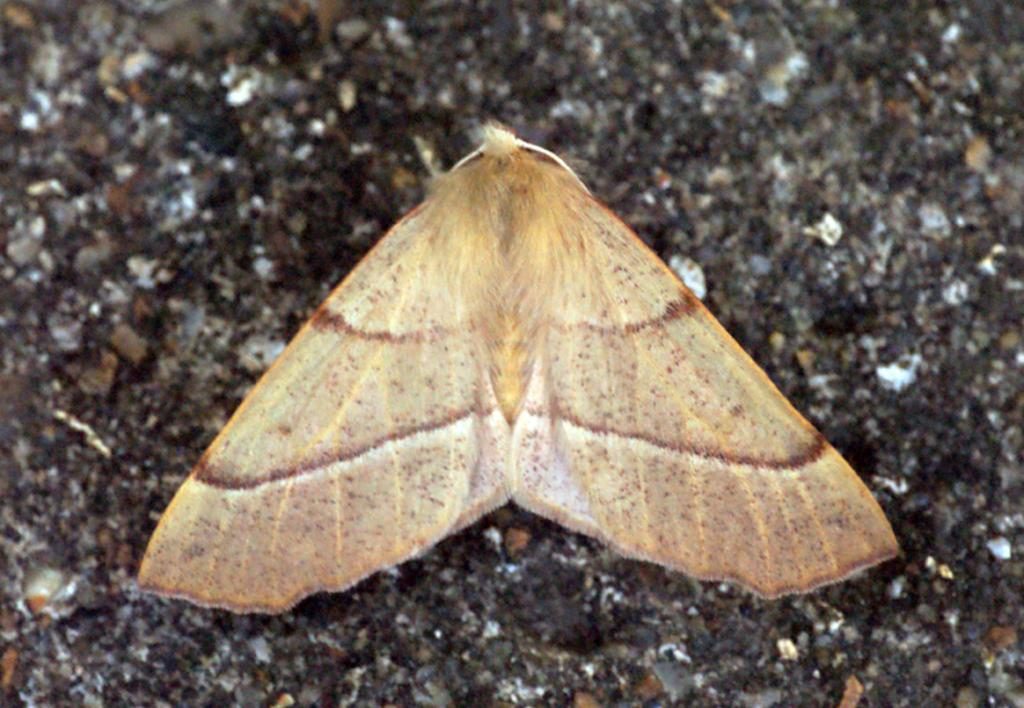What type of creature can be seen in the image? There is an insect in the image. Where is the insect located in the image? The insect is on the ground. What type of mother can be seen in the image? There is no mother present in the image; it features an insect on the ground. Is there a bear visible in the image? There is no bear present in the image; it features an insect on the ground. 